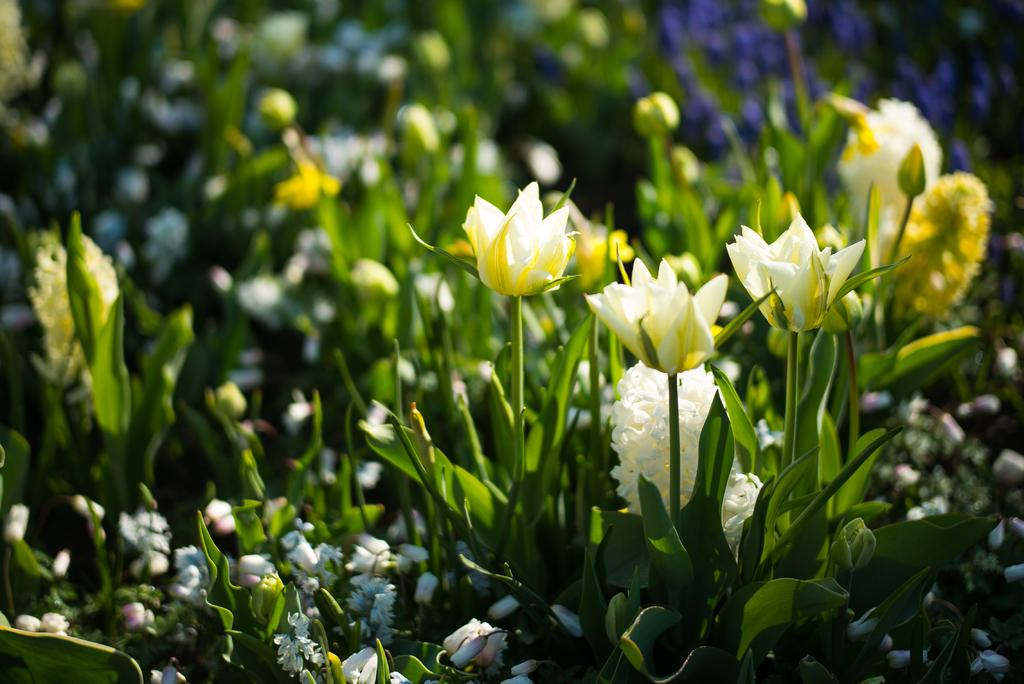What is the main subject in the foreground of the image? There are beautiful flowers in the foreground of the image. What are the flowers growing on? The flowers are on plants. What can be seen in the background of the image? There are buds visible in the background of the image. What type of clock is hanging on the plant in the image? There is no clock present in the image; it features beautiful flowers on plants and buds in the background. 